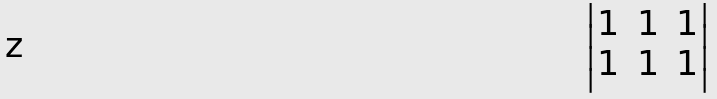<formula> <loc_0><loc_0><loc_500><loc_500>\begin{vmatrix} 1 & 1 & 1 \\ 1 & 1 & 1 \end{vmatrix}</formula> 